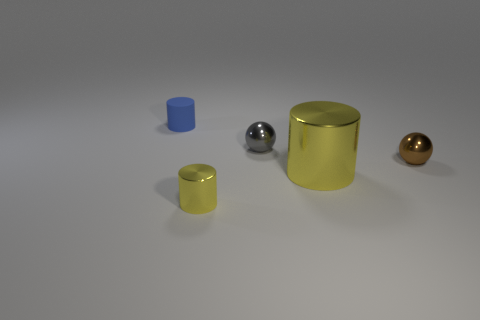There is a small thing that is in front of the tiny brown thing; does it have the same shape as the large yellow metal object?
Make the answer very short. Yes. There is another cylinder that is the same color as the tiny metal cylinder; what is it made of?
Provide a succinct answer. Metal. How many small objects have the same color as the big metal object?
Your response must be concise. 1. There is a yellow metallic object to the right of the small metallic thing in front of the small brown metal object; what is its shape?
Make the answer very short. Cylinder. Are there any purple rubber things that have the same shape as the small gray thing?
Offer a very short reply. No. There is a large object; is its color the same as the tiny metal sphere that is to the left of the big metallic cylinder?
Your response must be concise. No. The metal object that is the same color as the large cylinder is what size?
Your response must be concise. Small. Are there any cyan rubber things that have the same size as the brown thing?
Give a very brief answer. No. Does the big yellow cylinder have the same material as the tiny cylinder in front of the blue cylinder?
Give a very brief answer. Yes. Are there more brown balls than gray cylinders?
Make the answer very short. Yes. 